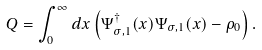Convert formula to latex. <formula><loc_0><loc_0><loc_500><loc_500>Q = \int ^ { \infty } _ { 0 } d x \left ( \Psi ^ { \dagger } _ { \sigma , 1 } ( x ) \Psi _ { \sigma , 1 } ( x ) - \rho _ { 0 } \right ) .</formula> 